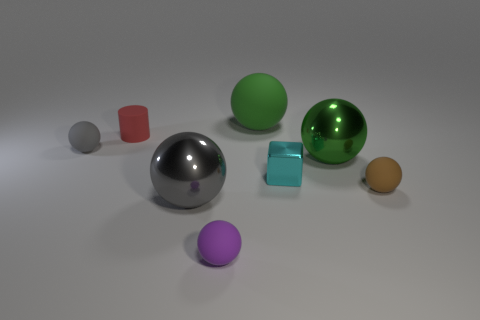How do the properties of the objects contrast with each other? The objects present a variety of textures and reflectiveness. Some are matte, like the clay or plastic-looking brown ball, while others, like the silver and green spheres, have highly reflective surfaces. These contrasts could be used to demonstrate different material properties, such as reflectivity, texture, and opacity. What might be the purpose of such a demonstration? The purpose might be educational or illustrative, perhaps to demonstrate how different materials interact with light, or it could be part of a visual composition study in photography or 3D modeling to understand color, reflection, and texture. 